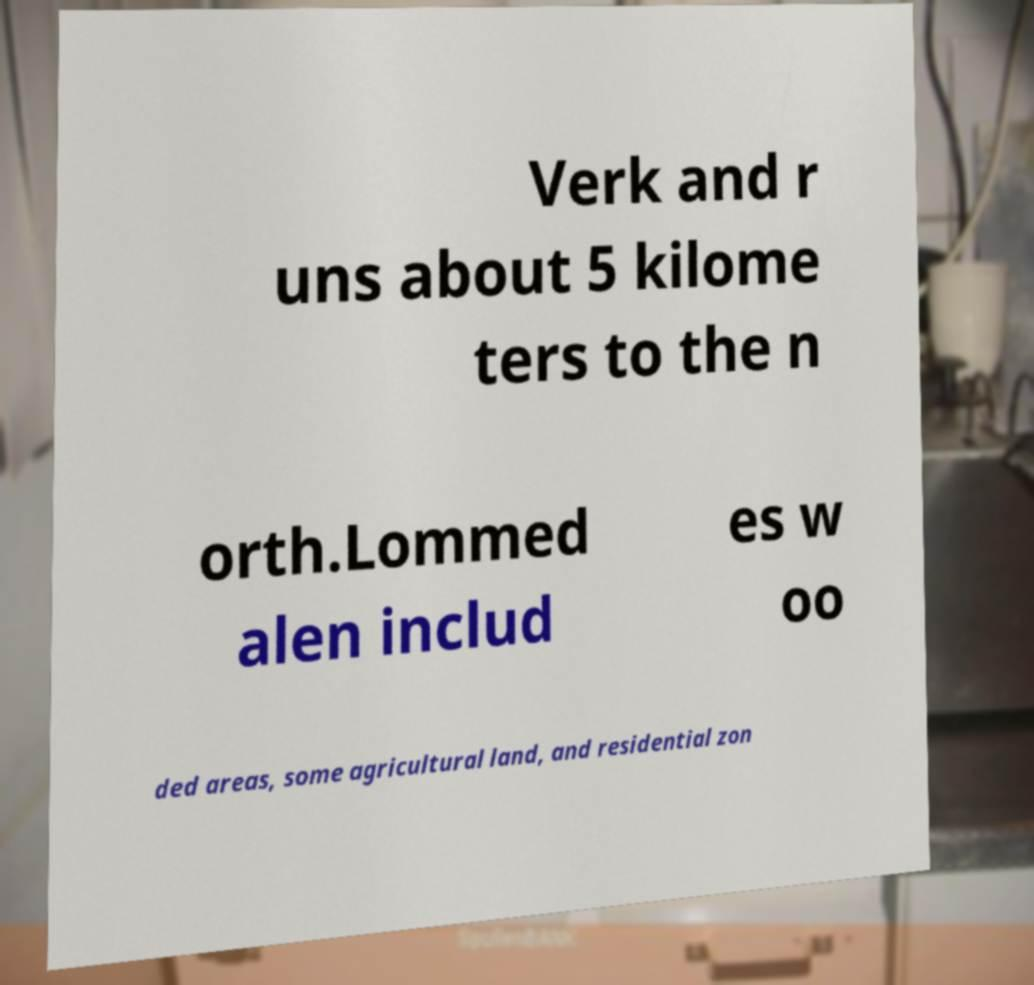Could you assist in decoding the text presented in this image and type it out clearly? Verk and r uns about 5 kilome ters to the n orth.Lommed alen includ es w oo ded areas, some agricultural land, and residential zon 